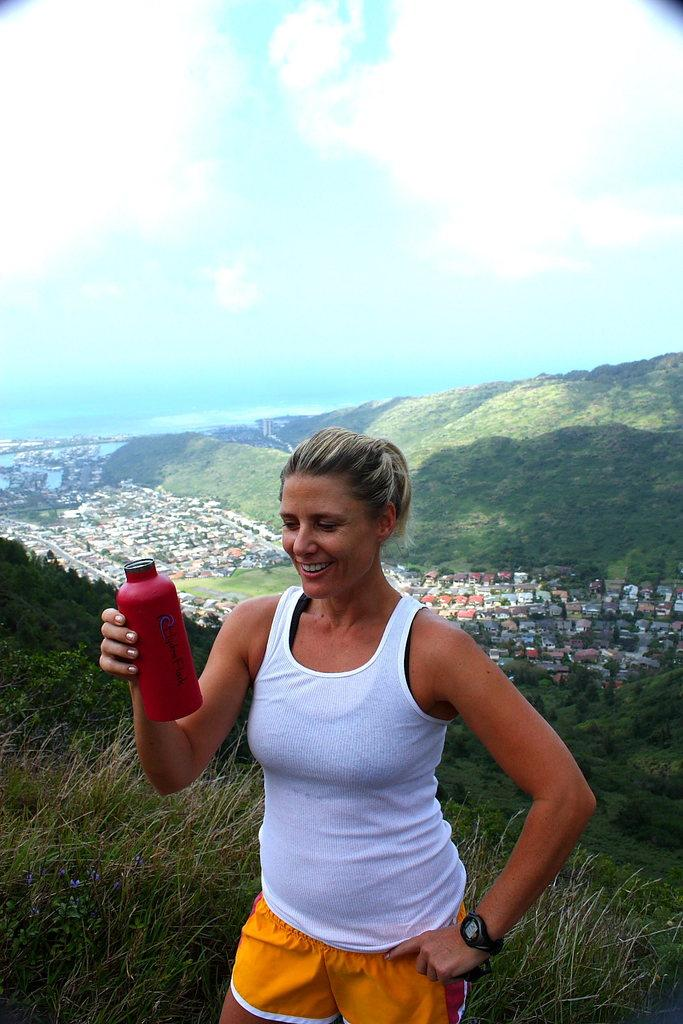Who is the main subject in the image? There is a woman in the picture. What is the woman holding in her right hand? The woman is holding a bottle in her right hand. What can be seen in the background of the image? There are beautiful houses and lands in the background of the image. What color is the sky in the background of the image? The sky is blue in the background of the image. What type of drain can be seen in the image? There is no drain present in the image. How many pages are visible in the image? There are no pages visible in the image. 